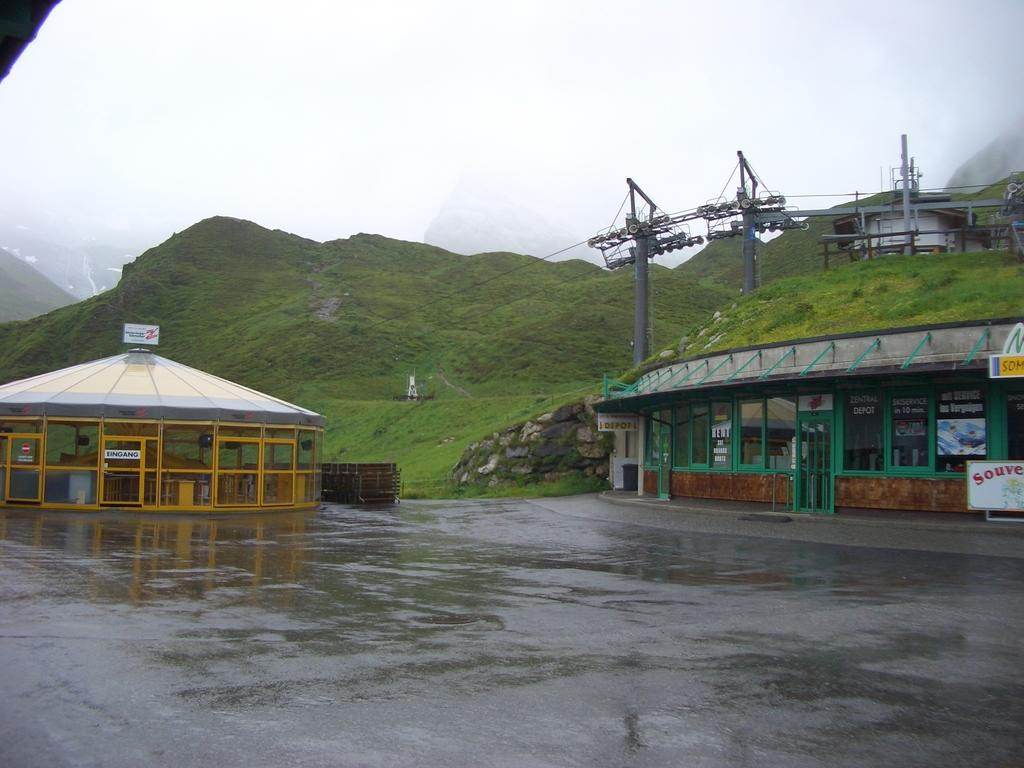What type of structures can be seen in the image? There are houses in the image. What type of vegetation is present in the image? There are trees in the image. What type of terrain is visible in the image? There is land visible in the image. What type of geographical feature can be seen in the image? There are hills in the image. What type of ray is emitting light from the earth in the image? There is no ray emitting light from the earth in the image. What type of scientific experiment is being conducted in the image? There is no scientific experiment being conducted in the image. 